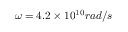Convert formula to latex. <formula><loc_0><loc_0><loc_500><loc_500>\omega = 4 . 2 \times 1 0 ^ { 1 0 } r a d / s</formula> 